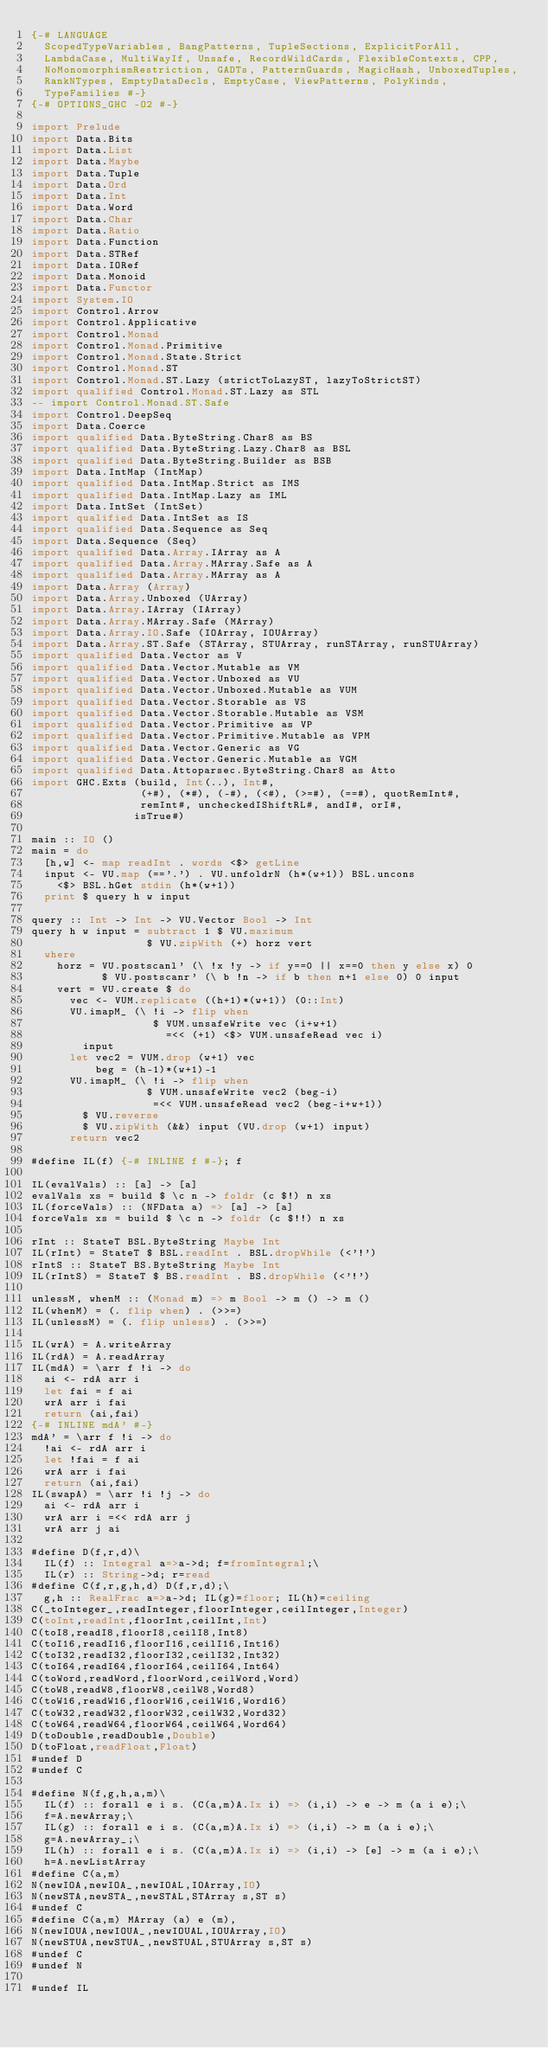Convert code to text. <code><loc_0><loc_0><loc_500><loc_500><_Haskell_>{-# LANGUAGE
  ScopedTypeVariables, BangPatterns, TupleSections, ExplicitForAll,
  LambdaCase, MultiWayIf, Unsafe, RecordWildCards, FlexibleContexts, CPP,
  NoMonomorphismRestriction, GADTs, PatternGuards, MagicHash, UnboxedTuples,
  RankNTypes, EmptyDataDecls, EmptyCase, ViewPatterns, PolyKinds,
  TypeFamilies #-}
{-# OPTIONS_GHC -O2 #-}

import Prelude
import Data.Bits
import Data.List
import Data.Maybe
import Data.Tuple
import Data.Ord
import Data.Int
import Data.Word
import Data.Char
import Data.Ratio
import Data.Function
import Data.STRef
import Data.IORef
import Data.Monoid
import Data.Functor
import System.IO
import Control.Arrow
import Control.Applicative
import Control.Monad
import Control.Monad.Primitive
import Control.Monad.State.Strict
import Control.Monad.ST
import Control.Monad.ST.Lazy (strictToLazyST, lazyToStrictST)
import qualified Control.Monad.ST.Lazy as STL
-- import Control.Monad.ST.Safe
import Control.DeepSeq
import Data.Coerce
import qualified Data.ByteString.Char8 as BS
import qualified Data.ByteString.Lazy.Char8 as BSL
import qualified Data.ByteString.Builder as BSB
import Data.IntMap (IntMap)
import qualified Data.IntMap.Strict as IMS
import qualified Data.IntMap.Lazy as IML
import Data.IntSet (IntSet)
import qualified Data.IntSet as IS
import qualified Data.Sequence as Seq
import Data.Sequence (Seq)
import qualified Data.Array.IArray as A
import qualified Data.Array.MArray.Safe as A
import qualified Data.Array.MArray as A
import Data.Array (Array)
import Data.Array.Unboxed (UArray)
import Data.Array.IArray (IArray)
import Data.Array.MArray.Safe (MArray)
import Data.Array.IO.Safe (IOArray, IOUArray)
import Data.Array.ST.Safe (STArray, STUArray, runSTArray, runSTUArray)
import qualified Data.Vector as V
import qualified Data.Vector.Mutable as VM
import qualified Data.Vector.Unboxed as VU
import qualified Data.Vector.Unboxed.Mutable as VUM
import qualified Data.Vector.Storable as VS
import qualified Data.Vector.Storable.Mutable as VSM
import qualified Data.Vector.Primitive as VP
import qualified Data.Vector.Primitive.Mutable as VPM
import qualified Data.Vector.Generic as VG
import qualified Data.Vector.Generic.Mutable as VGM
import qualified Data.Attoparsec.ByteString.Char8 as Atto
import GHC.Exts (build, Int(..), Int#,
                 (+#), (*#), (-#), (<#), (>=#), (==#), quotRemInt#,
                 remInt#, uncheckedIShiftRL#, andI#, orI#,
                isTrue#)

main :: IO ()
main = do
  [h,w] <- map readInt . words <$> getLine
  input <- VU.map (=='.') . VU.unfoldrN (h*(w+1)) BSL.uncons
    <$> BSL.hGet stdin (h*(w+1)) 
  print $ query h w input

query :: Int -> Int -> VU.Vector Bool -> Int
query h w input = subtract 1 $ VU.maximum
                  $ VU.zipWith (+) horz vert
  where
    horz = VU.postscanl' (\ !x !y -> if y==0 || x==0 then y else x) 0
           $ VU.postscanr' (\ b !n -> if b then n+1 else 0) 0 input
    vert = VU.create $ do
      vec <- VUM.replicate ((h+1)*(w+1)) (0::Int)
      VU.imapM_ (\ !i -> flip when
                   $ VUM.unsafeWrite vec (i+w+1)
                     =<< (+1) <$> VUM.unsafeRead vec i)
        input
      let vec2 = VUM.drop (w+1) vec
          beg = (h-1)*(w+1)-1
      VU.imapM_ (\ !i -> flip when
                  $ VUM.unsafeWrite vec2 (beg-i)
                   =<< VUM.unsafeRead vec2 (beg-i+w+1))
        $ VU.reverse
        $ VU.zipWith (&&) input (VU.drop (w+1) input)
      return vec2

#define IL(f) {-# INLINE f #-}; f

IL(evalVals) :: [a] -> [a]
evalVals xs = build $ \c n -> foldr (c $!) n xs
IL(forceVals) :: (NFData a) => [a] -> [a]
forceVals xs = build $ \c n -> foldr (c $!!) n xs

rInt :: StateT BSL.ByteString Maybe Int
IL(rInt) = StateT $ BSL.readInt . BSL.dropWhile (<'!')
rIntS :: StateT BS.ByteString Maybe Int
IL(rIntS) = StateT $ BS.readInt . BS.dropWhile (<'!')

unlessM, whenM :: (Monad m) => m Bool -> m () -> m ()
IL(whenM) = (. flip when) . (>>=)
IL(unlessM) = (. flip unless) . (>>=)

IL(wrA) = A.writeArray
IL(rdA) = A.readArray
IL(mdA) = \arr f !i -> do
  ai <- rdA arr i
  let fai = f ai 
  wrA arr i fai
  return (ai,fai)
{-# INLINE mdA' #-}
mdA' = \arr f !i -> do
  !ai <- rdA arr i
  let !fai = f ai
  wrA arr i fai
  return (ai,fai)
IL(swapA) = \arr !i !j -> do
  ai <- rdA arr i
  wrA arr i =<< rdA arr j
  wrA arr j ai

#define D(f,r,d)\
  IL(f) :: Integral a=>a->d; f=fromIntegral;\
  IL(r) :: String->d; r=read
#define C(f,r,g,h,d) D(f,r,d);\
  g,h :: RealFrac a=>a->d; IL(g)=floor; IL(h)=ceiling
C(_toInteger_,readInteger,floorInteger,ceilInteger,Integer)
C(toInt,readInt,floorInt,ceilInt,Int)
C(toI8,readI8,floorI8,ceilI8,Int8)
C(toI16,readI16,floorI16,ceilI16,Int16)
C(toI32,readI32,floorI32,ceilI32,Int32)
C(toI64,readI64,floorI64,ceilI64,Int64)
C(toWord,readWord,floorWord,ceilWord,Word)
C(toW8,readW8,floorW8,ceilW8,Word8)
C(toW16,readW16,floorW16,ceilW16,Word16)
C(toW32,readW32,floorW32,ceilW32,Word32)
C(toW64,readW64,floorW64,ceilW64,Word64)
D(toDouble,readDouble,Double)
D(toFloat,readFloat,Float)
#undef D
#undef C

#define N(f,g,h,a,m)\
  IL(f) :: forall e i s. (C(a,m)A.Ix i) => (i,i) -> e -> m (a i e);\
  f=A.newArray;\
  IL(g) :: forall e i s. (C(a,m)A.Ix i) => (i,i) -> m (a i e);\
  g=A.newArray_;\
  IL(h) :: forall e i s. (C(a,m)A.Ix i) => (i,i) -> [e] -> m (a i e);\
  h=A.newListArray
#define C(a,m)
N(newIOA,newIOA_,newIOAL,IOArray,IO)
N(newSTA,newSTA_,newSTAL,STArray s,ST s)
#undef C
#define C(a,m) MArray (a) e (m), 
N(newIOUA,newIOUA_,newIOUAL,IOUArray,IO)
N(newSTUA,newSTUA_,newSTUAL,STUArray s,ST s)
#undef C
#undef N

#undef IL
</code> 